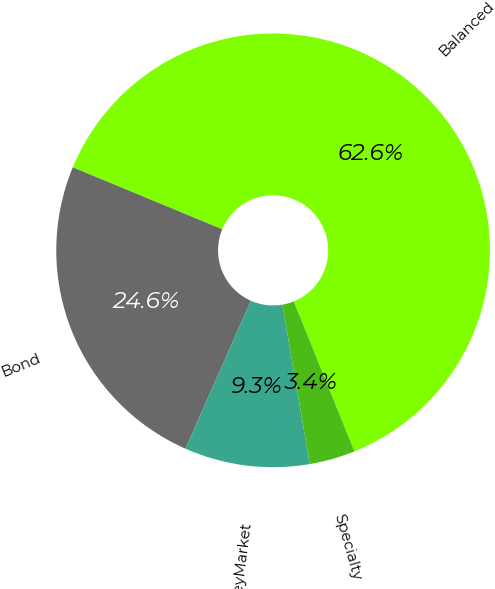<chart> <loc_0><loc_0><loc_500><loc_500><pie_chart><fcel>Balanced<fcel>Bond<fcel>MoneyMarket<fcel>Specialty<nl><fcel>62.63%<fcel>24.63%<fcel>9.33%<fcel>3.41%<nl></chart> 